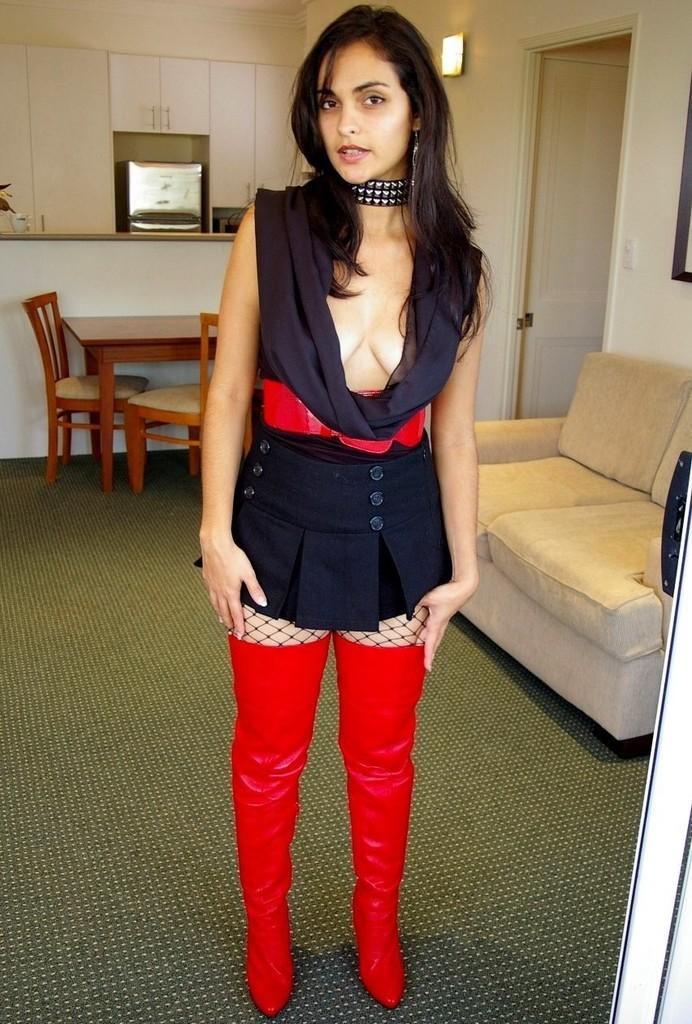Who is present in the image? There is a lady in the image. What is the lady doing in the image? The lady is standing on the floor. What type of footwear is the lady wearing? The lady is wearing red long boots. What can be seen in the background of the image? There is a sofa, a dining table, and a door in the background of the image. How many pies are on the floor in the image? There are no pies present in the image. What type of trail can be seen on the floor in the image? There is no trail visible on the floor in the image. 